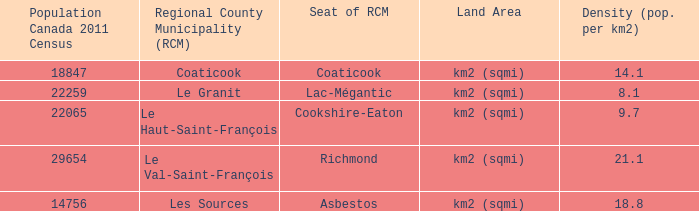Give me the full table as a dictionary. {'header': ['Population Canada 2011 Census', 'Regional County Municipality (RCM)', 'Seat of RCM', 'Land Area', 'Density (pop. per km2)'], 'rows': [['18847', 'Coaticook', 'Coaticook', 'km2 (sqmi)', '14.1'], ['22259', 'Le Granit', 'Lac-Mégantic', 'km2 (sqmi)', '8.1'], ['22065', 'Le Haut-Saint-François', 'Cookshire-Eaton', 'km2 (sqmi)', '9.7'], ['29654', 'Le Val-Saint-François', 'Richmond', 'km2 (sqmi)', '21.1'], ['14756', 'Les Sources', 'Asbestos', 'km2 (sqmi)', '18.8']]} What is the seat of the RCM in the county that has a density of 9.7? Cookshire-Eaton. 